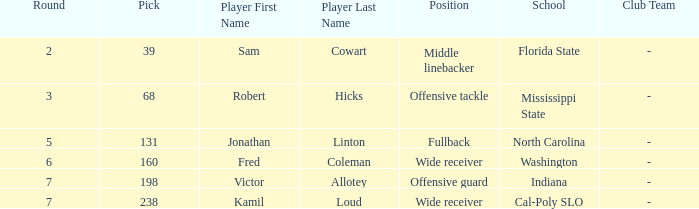Which School/Club Team has a Pick of 198? Indiana. 